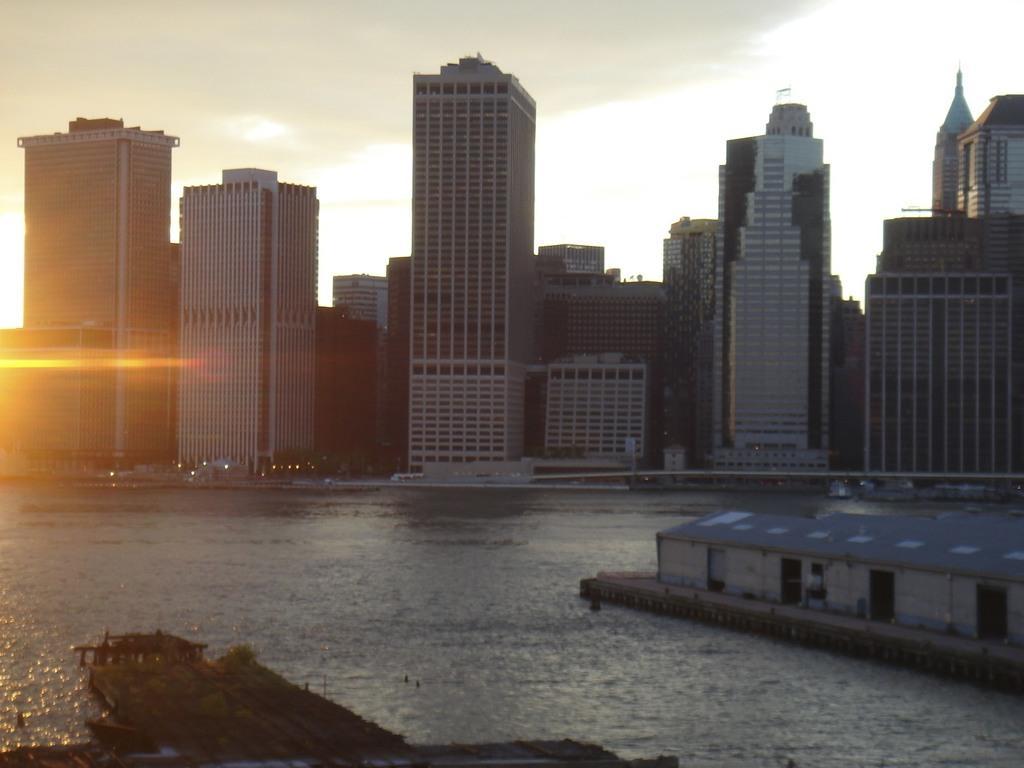Please provide a concise description of this image. In this picture there is a river water and blue color ware house on the right corner of the image. In the background we can see many skyscrapers. 